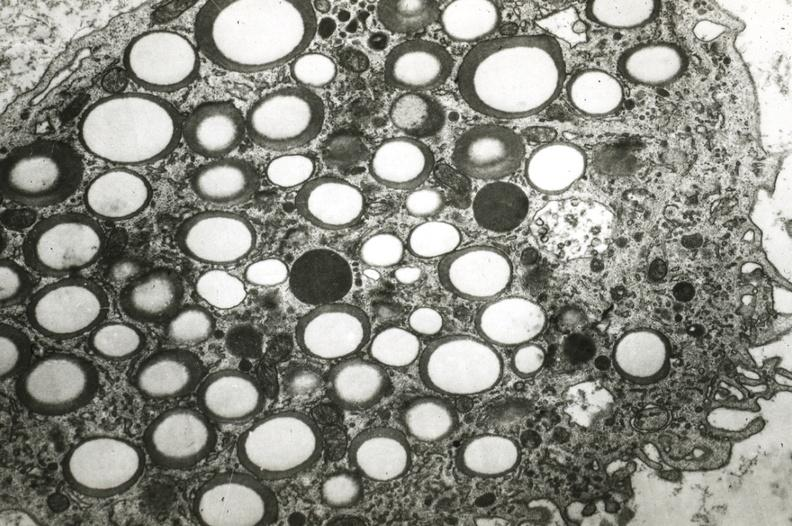what is present?
Answer the question using a single word or phrase. Vasculature 